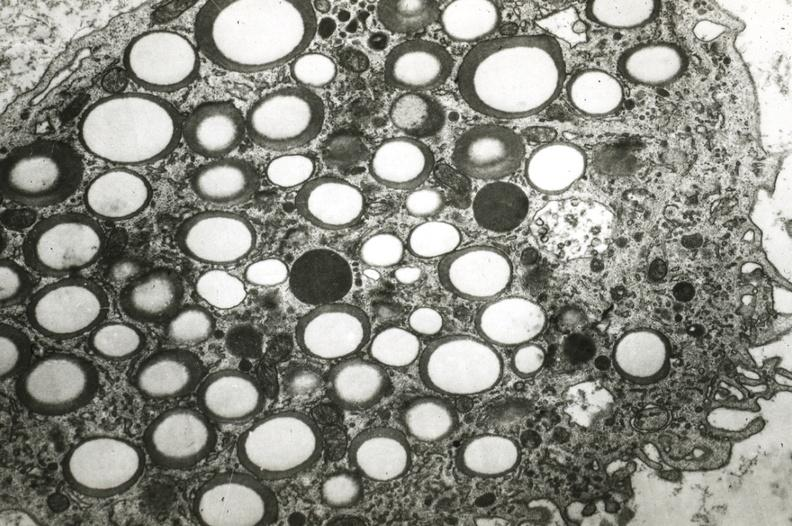what is present?
Answer the question using a single word or phrase. Vasculature 